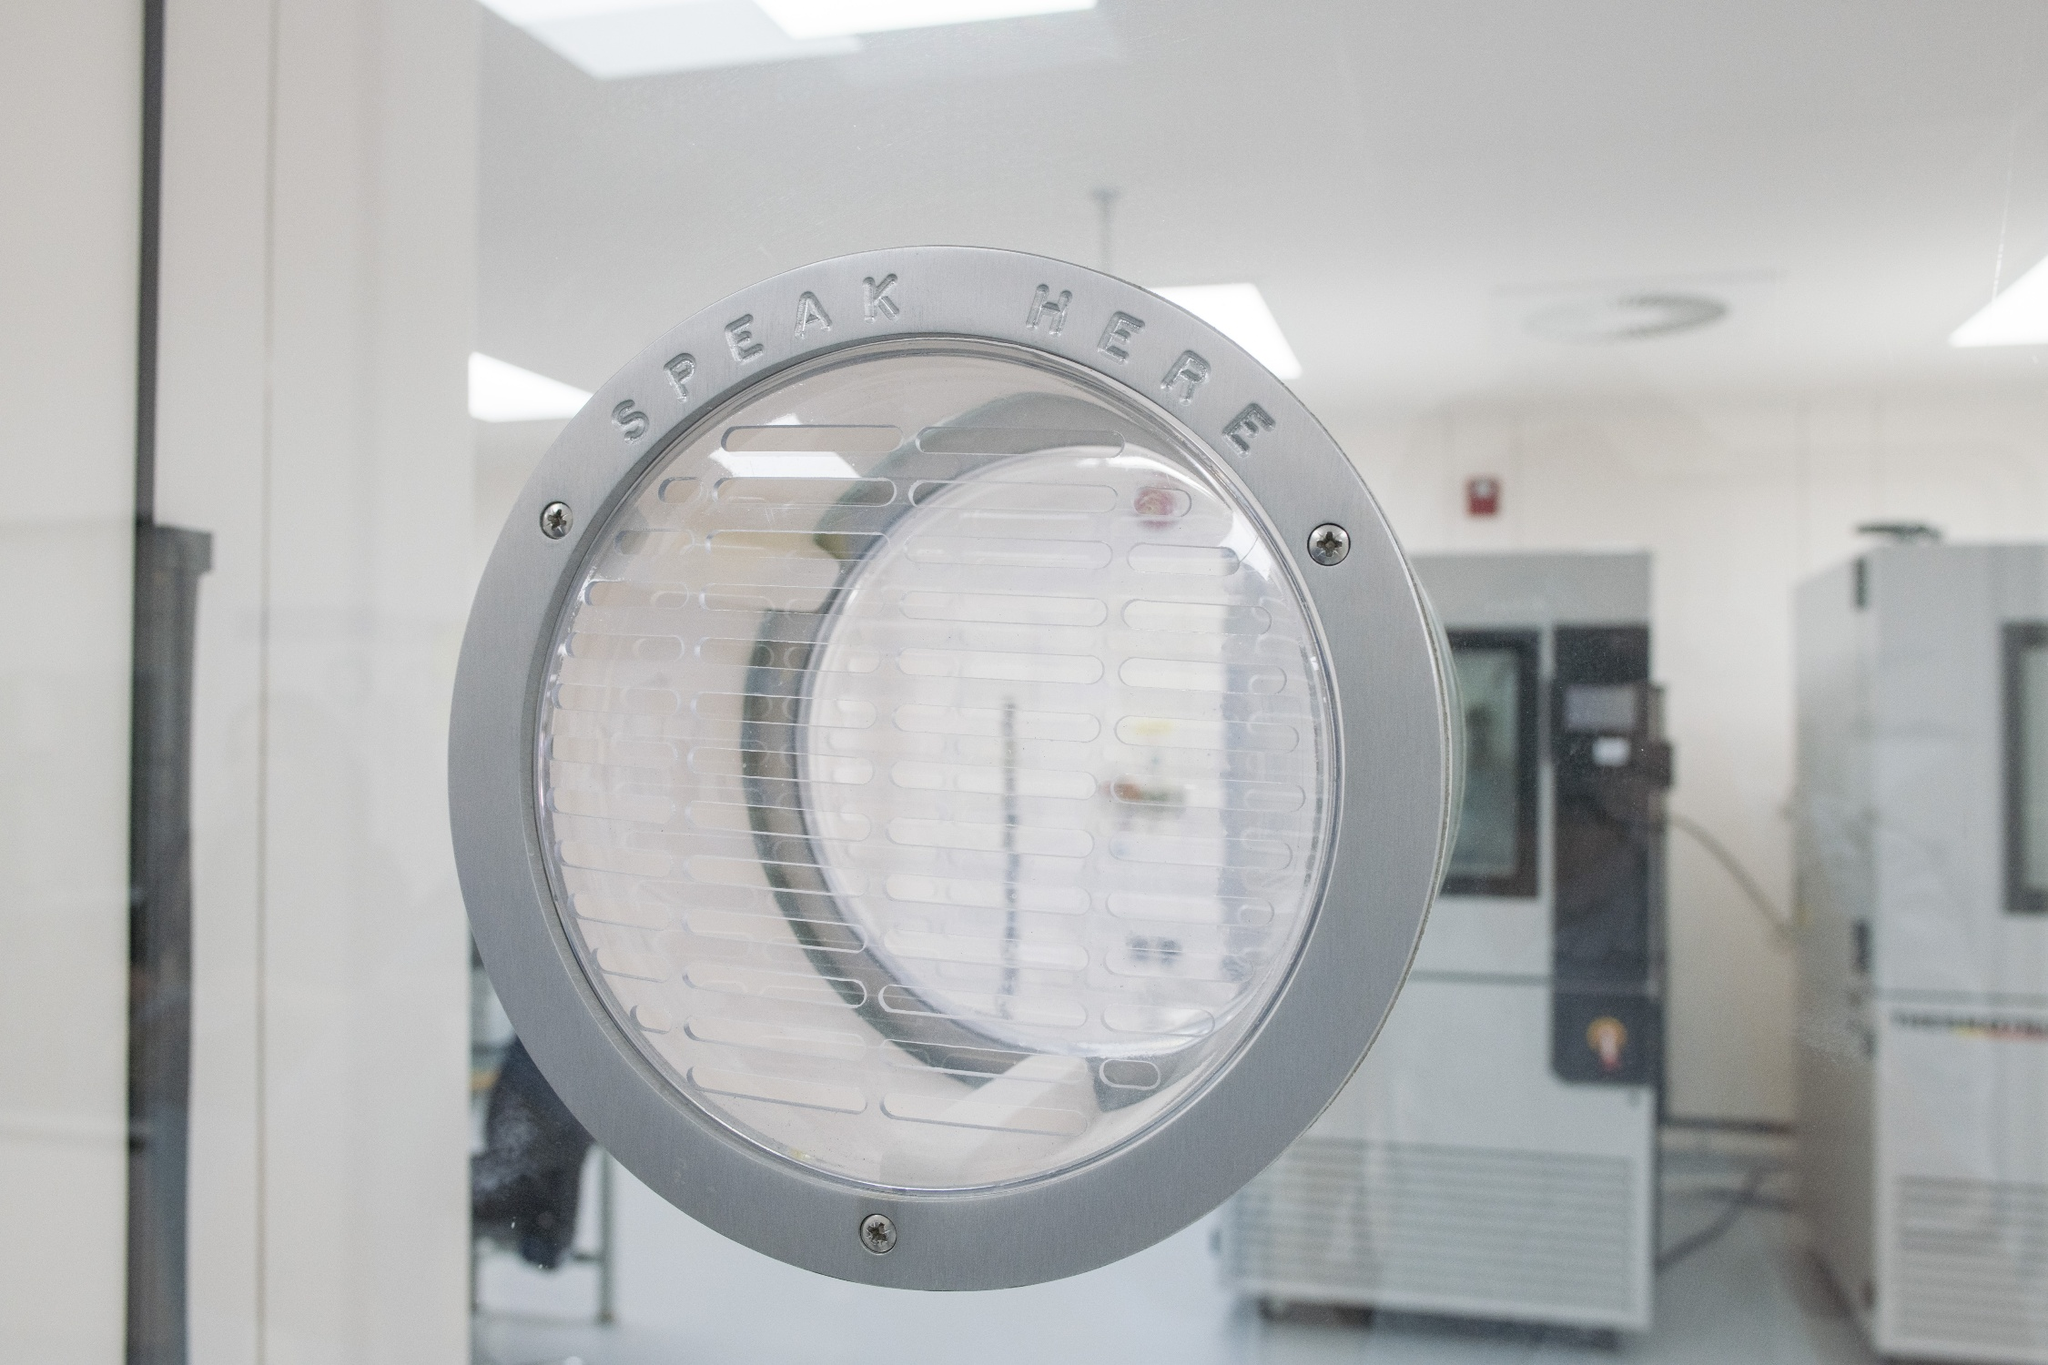What kind of equipment is visible in the background of the image? The blurred background reveals equipment that appears to be part of a laboratory or medical environment. There are machines with control panels, likely used for various testing or processing activities. These could include incubators, freezers, or other specialized apparatus designed for scientific or medical use, emphasizing the professional and controlled nature of the setting. Imagine a future where this intercom can do more than just transfer voice. What features could it have? In a futuristic scenario, this intercom could be equipped with advanced features such as real-time translation, allowing individuals speaking different languages to communicate seamlessly. It might also integrate with augmented reality (AR) to provide visual cues and instructions, enhancing user interaction. Additionally, it could have biometric security features, such as voice recognition or facial scanning, to ensure that only authorized personnel can use the communication system. These upgrades would greatly enhance the capabilities and security of communication within high-stakes environments. What are the challenges associated with maintaining such an intercom system in a controlled environment? Maintaining an intercom system in a controlled environment presents several challenges. First, the system must be regularly cleaned and sanitized to prevent contamination, especially in sterile settings like cleanrooms. It must also be robust enough to withstand rigorous usage while ensuring consistent audio clarity. Technical maintenance is crucial, as any malfunction could disrupt communication, potentially leading to safety or operational issues. Furthermore, integrating advanced features like real-time translation or biometric security would require addressing privacy concerns and ensuring the intercom meets stringent regulatory standards for use in secure and sterile environments. 